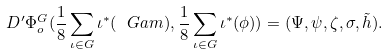Convert formula to latex. <formula><loc_0><loc_0><loc_500><loc_500>D ^ { \prime } \Phi ^ { G } _ { o } ( \frac { 1 } { 8 } \sum _ { \iota \in G } \iota ^ { * } ( \ G a m ) , \frac { 1 } { 8 } \sum _ { \iota \in G } \iota ^ { * } ( \phi ) ) = ( \Psi , \psi , \zeta , \sigma , \tilde { h } ) .</formula> 